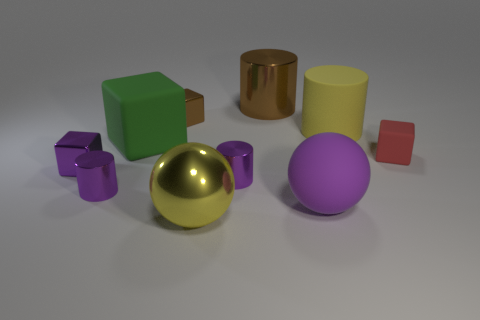Subtract 1 cylinders. How many cylinders are left? 3 Subtract all cylinders. How many objects are left? 6 Add 4 large metallic cylinders. How many large metallic cylinders are left? 5 Add 6 small red blocks. How many small red blocks exist? 7 Subtract 0 gray blocks. How many objects are left? 10 Subtract all shiny cylinders. Subtract all small brown things. How many objects are left? 6 